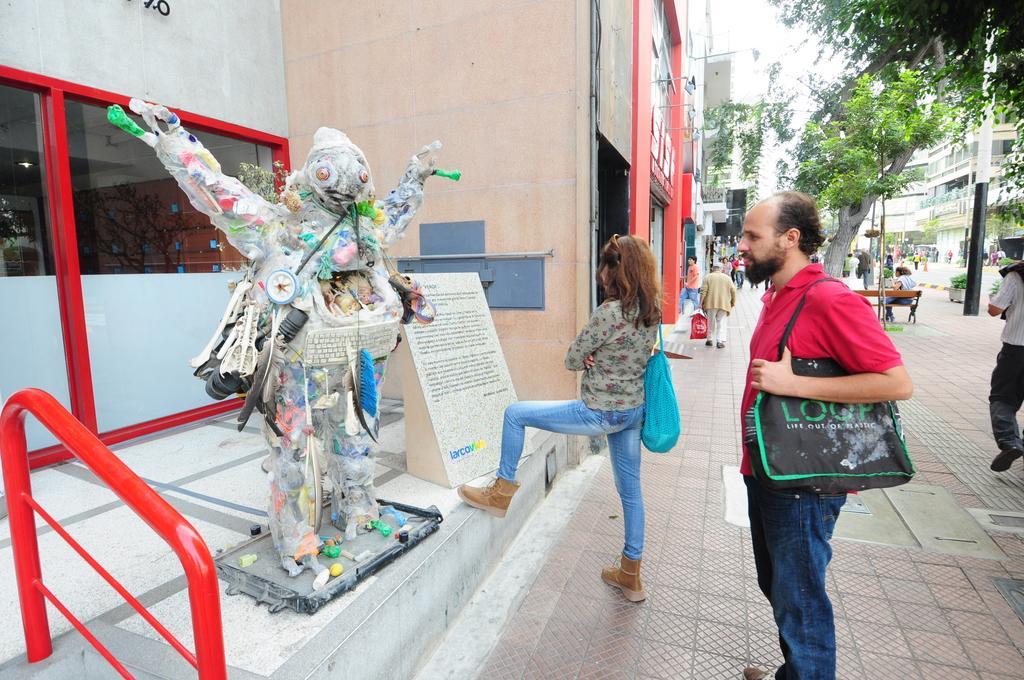Describe this image in one or two sentences. In this image I can see the ground, few persons are standing holding bags, a statue, the railing, few persons standing, a person sitting, few trees, few poles, few buildings, and few trees. In the background I can see the sky. 